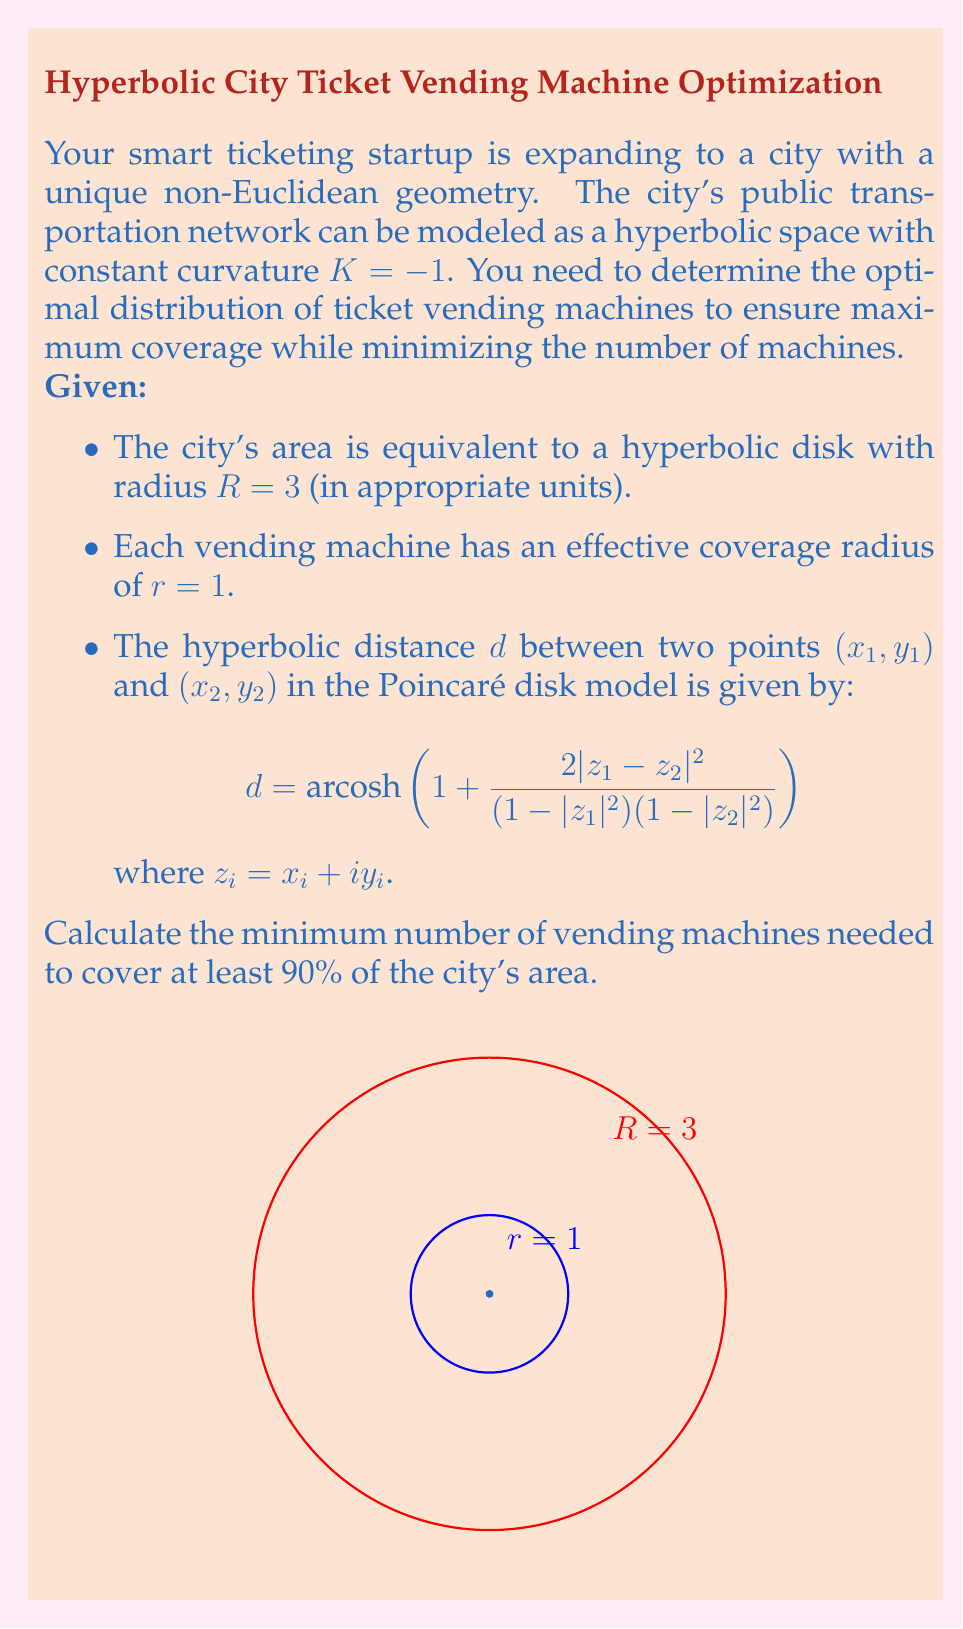What is the answer to this math problem? Let's approach this problem step-by-step:

1) In hyperbolic geometry, the area of a disk with radius $r$ is given by:
   $$A(r) = 4\pi \sinh^2(r/2)$$

2) The area of the entire city (disk with radius $R=3$) is:
   $$A(3) = 4\pi \sinh^2(3/2) \approx 85.29$$

3) The area of a single vending machine's coverage (disk with radius $r=1$) is:
   $$A(1) = 4\pi \sinh^2(1/2) \approx 3.62$$

4) To cover 90% of the city, we need to cover an area of:
   $$0.9 \times 85.29 \approx 76.76$$

5) In Euclidean space, we could simply divide the required area by the area of a single machine's coverage. However, in hyperbolic space, there will be overlaps between the coverage areas that increase as we add more machines.

6) To account for this, we can use the concept of hyperbolic packing. The best known packing density for equal circles in the hyperbolic plane is approximately 0.853.

7) Therefore, the effective area covered by each machine is:
   $$3.62 \times 0.853 \approx 3.09$$

8) The number of machines needed is thus:
   $$\frac{76.76}{3.09} \approx 24.84$$

9) Rounding up to ensure at least 90% coverage, we get 25 machines.
Answer: 25 vending machines 